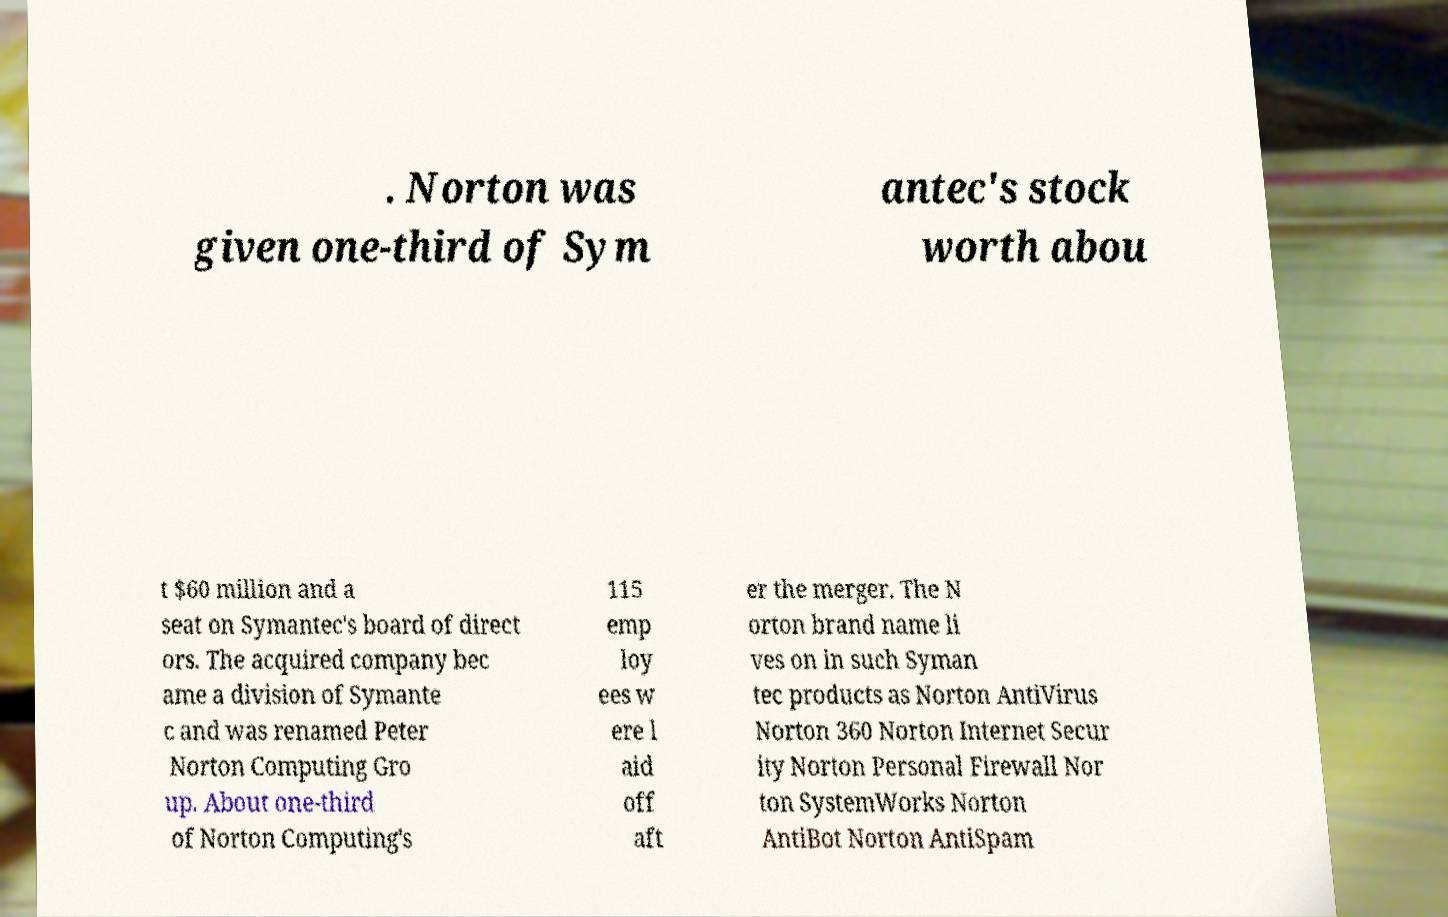Can you accurately transcribe the text from the provided image for me? . Norton was given one-third of Sym antec's stock worth abou t $60 million and a seat on Symantec's board of direct ors. The acquired company bec ame a division of Symante c and was renamed Peter Norton Computing Gro up. About one-third of Norton Computing's 115 emp loy ees w ere l aid off aft er the merger. The N orton brand name li ves on in such Syman tec products as Norton AntiVirus Norton 360 Norton Internet Secur ity Norton Personal Firewall Nor ton SystemWorks Norton AntiBot Norton AntiSpam 